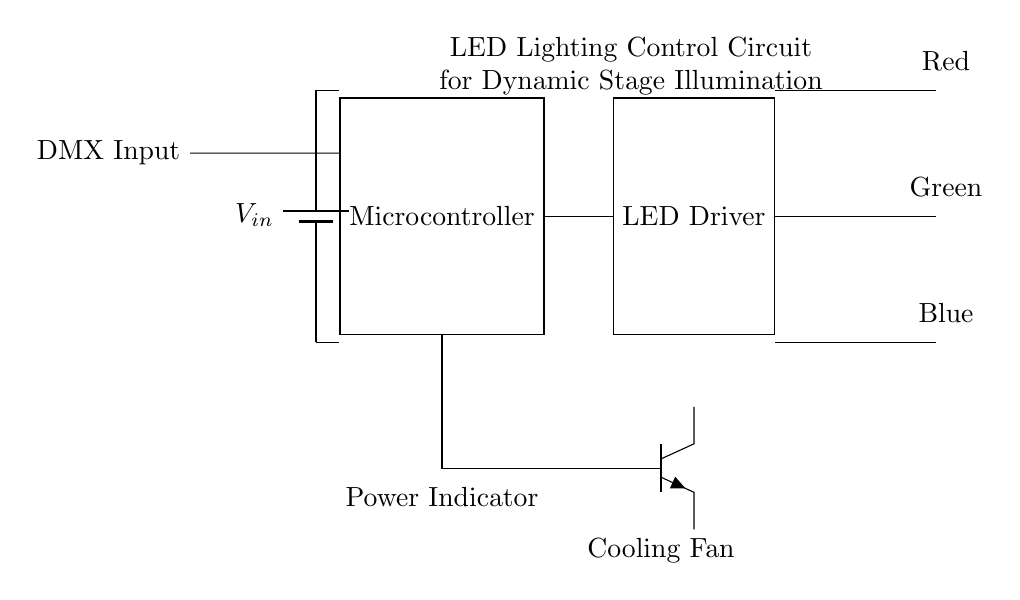What type of input does this circuit accept? The circuit diagram shows a "DMX Input" on the left side, indicating the circuit accepts DMX input control signals.
Answer: DMX Input How many types of LEDs are shown in the circuit? The circuit displays three LEDs in different colors: red, green, and blue. This indicates there are three types of LEDs.
Answer: Three What component controls the LEDs in this circuit? The "LED Driver" is the component designated to drive and control the LEDs based on the signals from the microcontroller.
Answer: LED Driver What function does the cooling fan serve in this circuit? The cooling fan is connected to the microcontroller to help prevent overheating during operation, ensuring components remain within operational temperature limits.
Answer: Cooling What is the purpose of the power indicator in the circuit? The power indicator, represented as a yellow LED, shows whether the circuit is receiving power or is operational, acting as a visual status indicator for users.
Answer: Power Indicator How is the microcontroller powered in this circuit? The microcontroller receives power from the battery, as indicated by the connection from the battery to the microcontroller input in the top left of the circuit.
Answer: Battery 